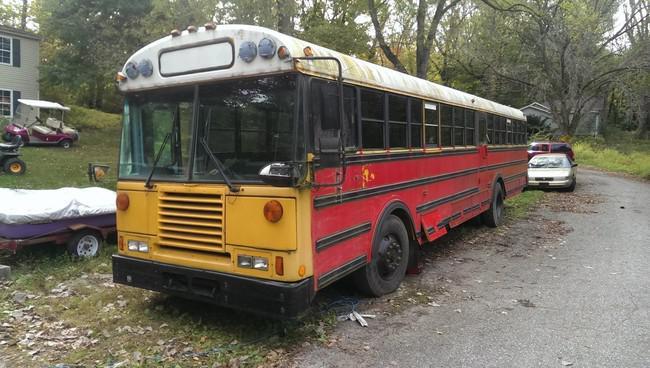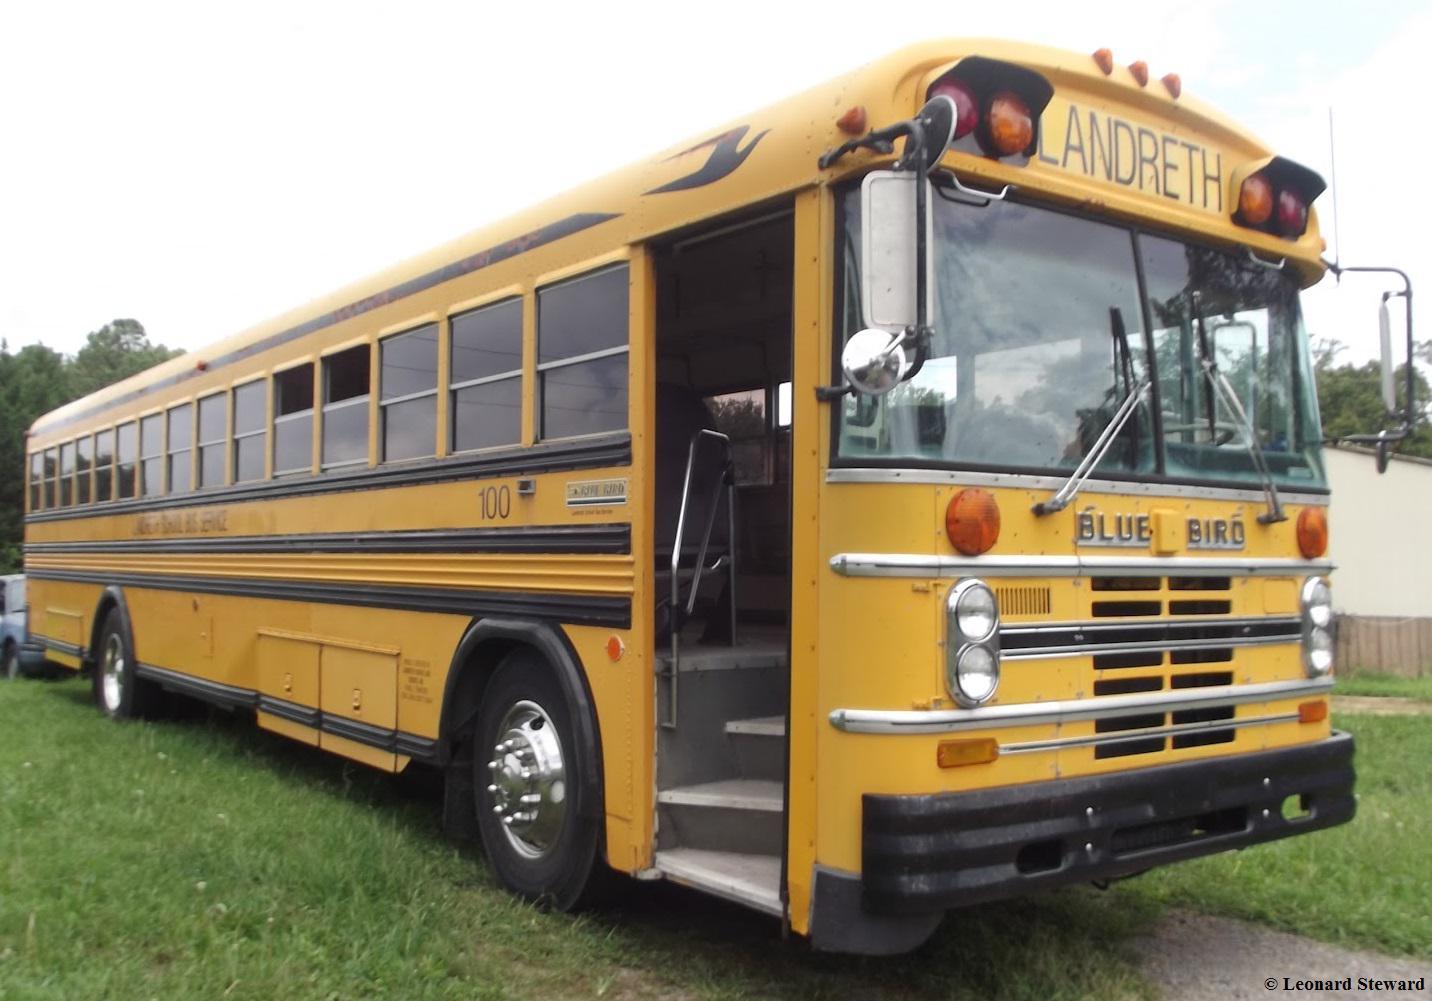The first image is the image on the left, the second image is the image on the right. Assess this claim about the two images: "Both buses are facing diagonally and to the same side.". Correct or not? Answer yes or no. No. The first image is the image on the left, the second image is the image on the right. For the images shown, is this caption "Exactly one bus' doors are open." true? Answer yes or no. Yes. 